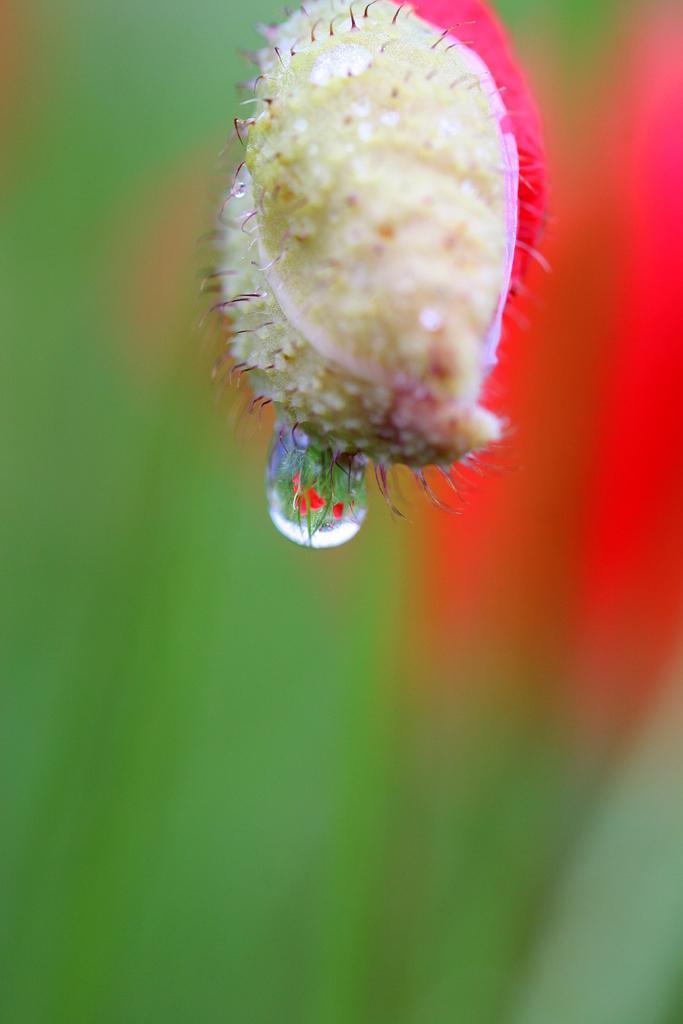Could you give a brief overview of what you see in this image? In this image there is a dew drop on the flower. 